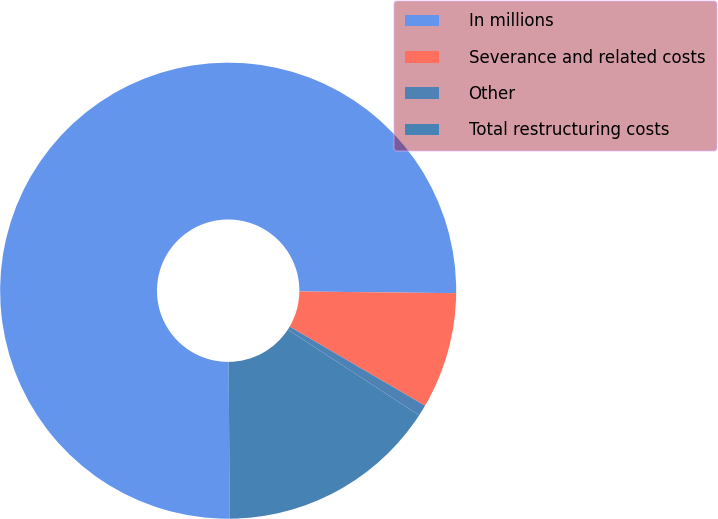Convert chart to OTSL. <chart><loc_0><loc_0><loc_500><loc_500><pie_chart><fcel>In millions<fcel>Severance and related costs<fcel>Other<fcel>Total restructuring costs<nl><fcel>75.29%<fcel>8.24%<fcel>0.79%<fcel>15.69%<nl></chart> 